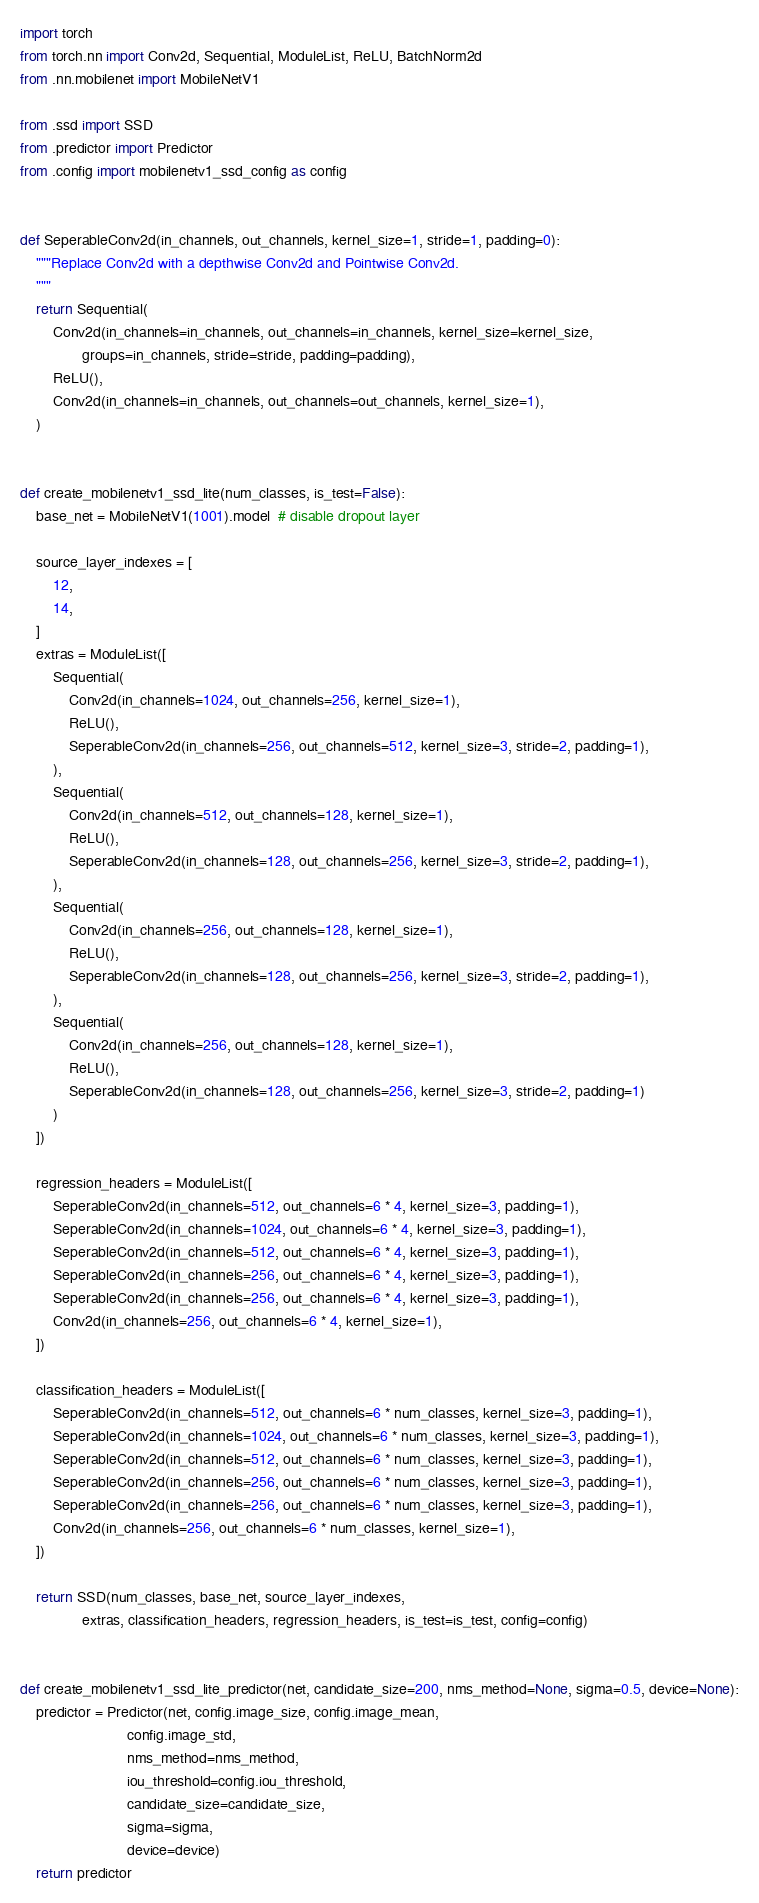<code> <loc_0><loc_0><loc_500><loc_500><_Python_>import torch
from torch.nn import Conv2d, Sequential, ModuleList, ReLU, BatchNorm2d
from .nn.mobilenet import MobileNetV1

from .ssd import SSD
from .predictor import Predictor
from .config import mobilenetv1_ssd_config as config


def SeperableConv2d(in_channels, out_channels, kernel_size=1, stride=1, padding=0):
    """Replace Conv2d with a depthwise Conv2d and Pointwise Conv2d.
    """
    return Sequential(
        Conv2d(in_channels=in_channels, out_channels=in_channels, kernel_size=kernel_size,
               groups=in_channels, stride=stride, padding=padding),
        ReLU(),
        Conv2d(in_channels=in_channels, out_channels=out_channels, kernel_size=1),
    )


def create_mobilenetv1_ssd_lite(num_classes, is_test=False):
    base_net = MobileNetV1(1001).model  # disable dropout layer

    source_layer_indexes = [
        12,
        14,
    ]
    extras = ModuleList([
        Sequential(
            Conv2d(in_channels=1024, out_channels=256, kernel_size=1),
            ReLU(),
            SeperableConv2d(in_channels=256, out_channels=512, kernel_size=3, stride=2, padding=1),
        ),
        Sequential(
            Conv2d(in_channels=512, out_channels=128, kernel_size=1),
            ReLU(),
            SeperableConv2d(in_channels=128, out_channels=256, kernel_size=3, stride=2, padding=1),
        ),
        Sequential(
            Conv2d(in_channels=256, out_channels=128, kernel_size=1),
            ReLU(),
            SeperableConv2d(in_channels=128, out_channels=256, kernel_size=3, stride=2, padding=1),
        ),
        Sequential(
            Conv2d(in_channels=256, out_channels=128, kernel_size=1),
            ReLU(),
            SeperableConv2d(in_channels=128, out_channels=256, kernel_size=3, stride=2, padding=1)
        )
    ])

    regression_headers = ModuleList([
        SeperableConv2d(in_channels=512, out_channels=6 * 4, kernel_size=3, padding=1),
        SeperableConv2d(in_channels=1024, out_channels=6 * 4, kernel_size=3, padding=1),
        SeperableConv2d(in_channels=512, out_channels=6 * 4, kernel_size=3, padding=1),
        SeperableConv2d(in_channels=256, out_channels=6 * 4, kernel_size=3, padding=1),
        SeperableConv2d(in_channels=256, out_channels=6 * 4, kernel_size=3, padding=1),
        Conv2d(in_channels=256, out_channels=6 * 4, kernel_size=1),
    ])

    classification_headers = ModuleList([
        SeperableConv2d(in_channels=512, out_channels=6 * num_classes, kernel_size=3, padding=1),
        SeperableConv2d(in_channels=1024, out_channels=6 * num_classes, kernel_size=3, padding=1),
        SeperableConv2d(in_channels=512, out_channels=6 * num_classes, kernel_size=3, padding=1),
        SeperableConv2d(in_channels=256, out_channels=6 * num_classes, kernel_size=3, padding=1),
        SeperableConv2d(in_channels=256, out_channels=6 * num_classes, kernel_size=3, padding=1),
        Conv2d(in_channels=256, out_channels=6 * num_classes, kernel_size=1),
    ])

    return SSD(num_classes, base_net, source_layer_indexes,
               extras, classification_headers, regression_headers, is_test=is_test, config=config)


def create_mobilenetv1_ssd_lite_predictor(net, candidate_size=200, nms_method=None, sigma=0.5, device=None):
    predictor = Predictor(net, config.image_size, config.image_mean,
                          config.image_std,
                          nms_method=nms_method,
                          iou_threshold=config.iou_threshold,
                          candidate_size=candidate_size,
                          sigma=sigma,
                          device=device)
    return predictor
</code> 